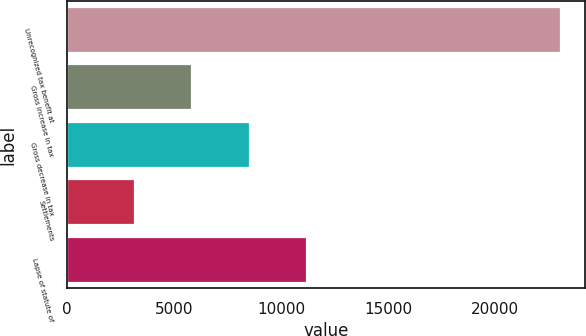<chart> <loc_0><loc_0><loc_500><loc_500><bar_chart><fcel>Unrecognized tax benefit at<fcel>Gross increase in tax<fcel>Gross decrease in tax<fcel>Settlements<fcel>Lapse of statute of<nl><fcel>23080<fcel>5858<fcel>8541<fcel>3175<fcel>11224<nl></chart> 